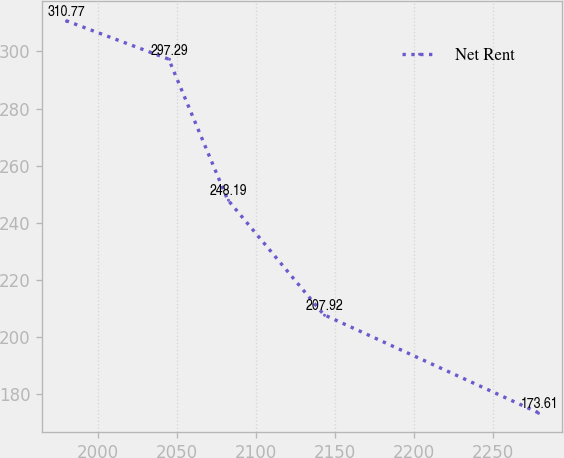<chart> <loc_0><loc_0><loc_500><loc_500><line_chart><ecel><fcel>Net Rent<nl><fcel>1979.8<fcel>310.77<nl><fcel>2044.91<fcel>297.29<nl><fcel>2082.14<fcel>248.19<nl><fcel>2143.03<fcel>207.92<nl><fcel>2278.82<fcel>173.61<nl></chart> 